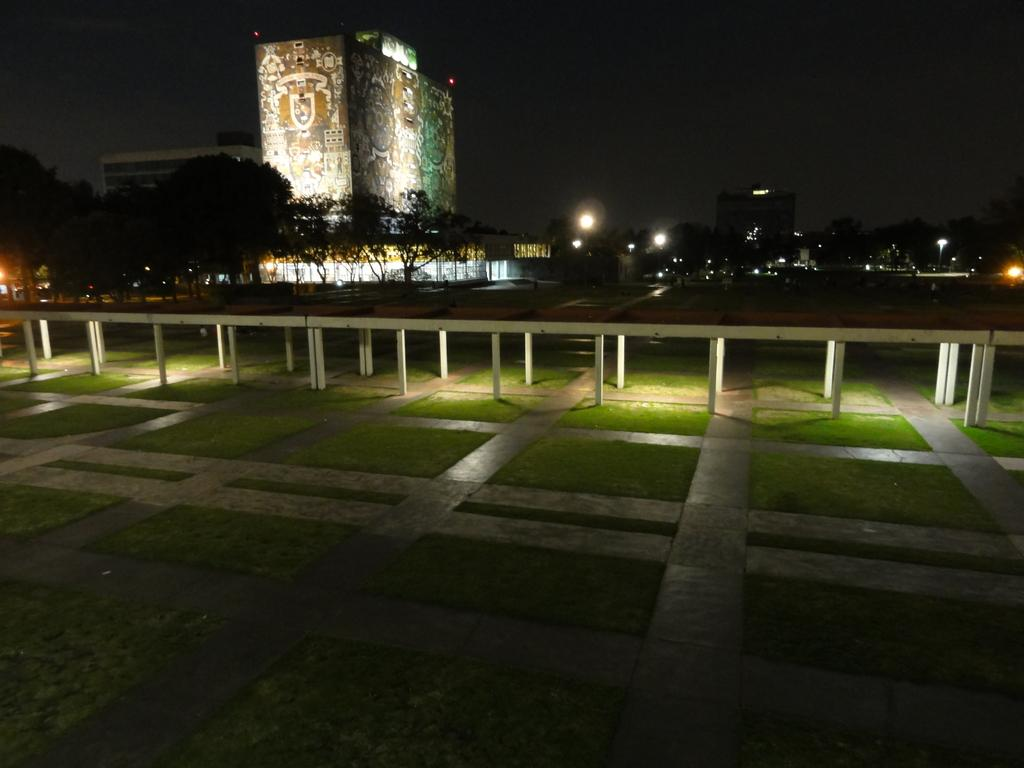What type of structures are present in the image? There are buildings in the image. What type of vegetation can be seen in the image? There are trees in the image. What can be seen illuminating the scene in the image? There are lights visible in the image. What type of ground cover is present in the image? There is grass on the ground in the image. Where is the mask hanging in the image? There is no mask present in the image. What type of smoke can be seen coming from the buildings in the image? There is no smoke visible in the image; the buildings are not on fire or emitting any visible emissions. 